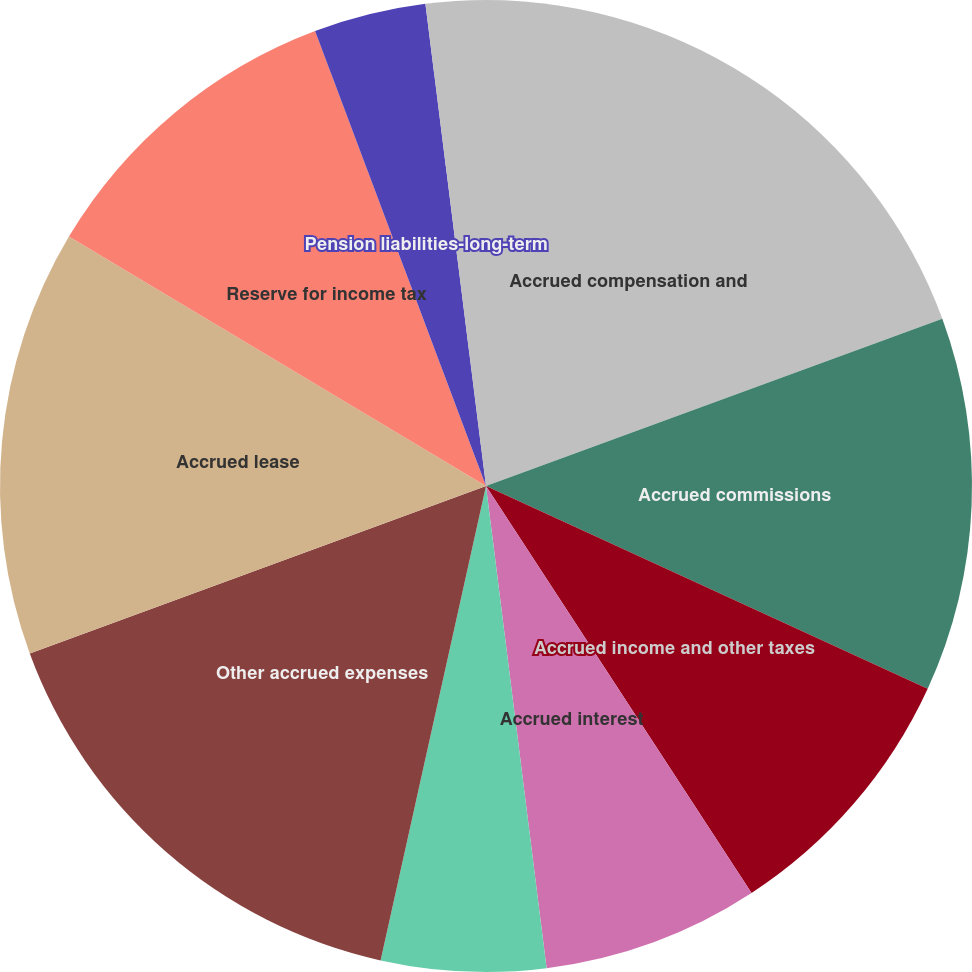<chart> <loc_0><loc_0><loc_500><loc_500><pie_chart><fcel>Accrued compensation and<fcel>Accrued commissions<fcel>Accrued income and other taxes<fcel>Accrued interest<fcel>Accrued warranty current<fcel>Other accrued expenses<fcel>Accrued lease<fcel>Reserve for income tax<fcel>Pension liabilities-long-term<fcel>Other<nl><fcel>19.41%<fcel>12.44%<fcel>8.95%<fcel>7.21%<fcel>5.47%<fcel>15.92%<fcel>14.18%<fcel>10.7%<fcel>3.73%<fcel>1.99%<nl></chart> 